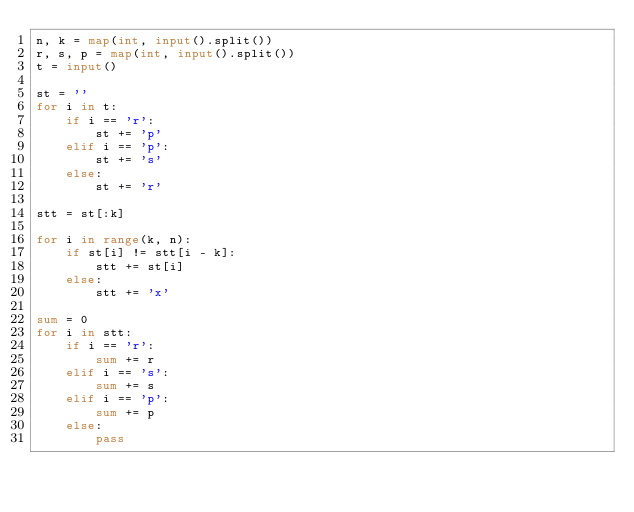Convert code to text. <code><loc_0><loc_0><loc_500><loc_500><_Python_>n, k = map(int, input().split())
r, s, p = map(int, input().split())
t = input()

st = ''
for i in t:
    if i == 'r':
        st += 'p'
    elif i == 'p':
        st += 's'
    else:
        st += 'r'

stt = st[:k]

for i in range(k, n):
    if st[i] != stt[i - k]:
        stt += st[i]
    else:
        stt += 'x'

sum = 0
for i in stt:
    if i == 'r':
        sum += r
    elif i == 's':
        sum += s
    elif i == 'p':
        sum += p
    else:
        pass</code> 